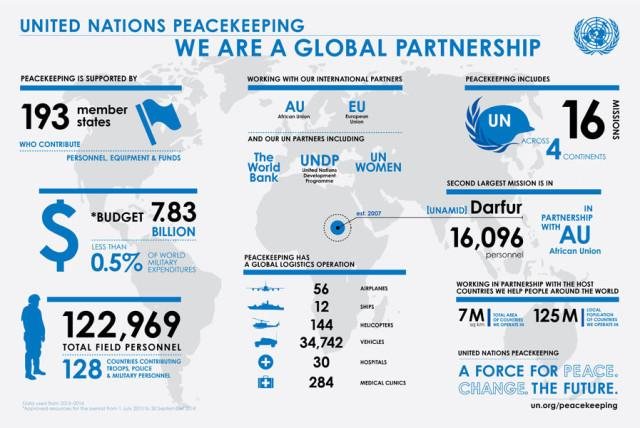List a handful of essential elements in this visual. As of the global logistics operation, a total of 314 hospitals and medical clinics are being utilized. The United Nations has two international partners for its peacekeeping missions. Out of the total number of countries that participate in United Nations peacekeeping missions, approximately 67 do not contribute troops, police, or military personnel. Thirty-three United Nations partner organizations are involved in peacekeeping missions around the world. The United Nations Development Programme (UNDP) is involved in peacekeeping missions and is a partner of the United Nations. 